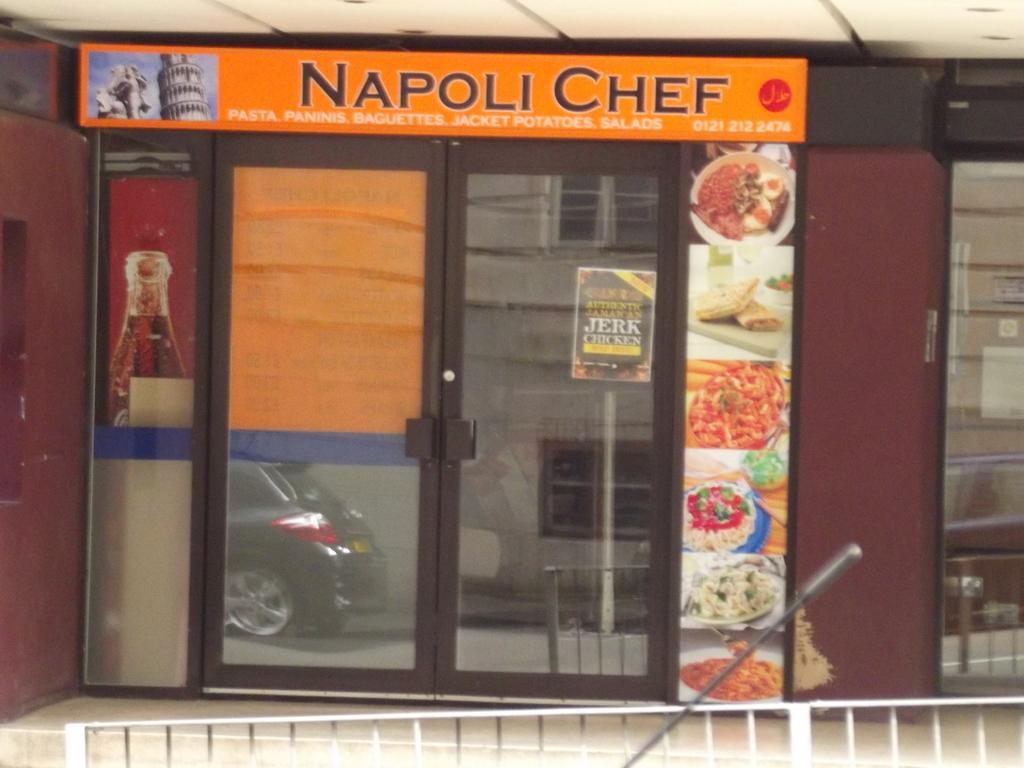Please provide a concise description of this image. In this image we can see a board, door, wall, hoardings, floor, railing, and an object. On the glass we can see the reflection of a building, vehicles, pole, board, windows, and railing. 